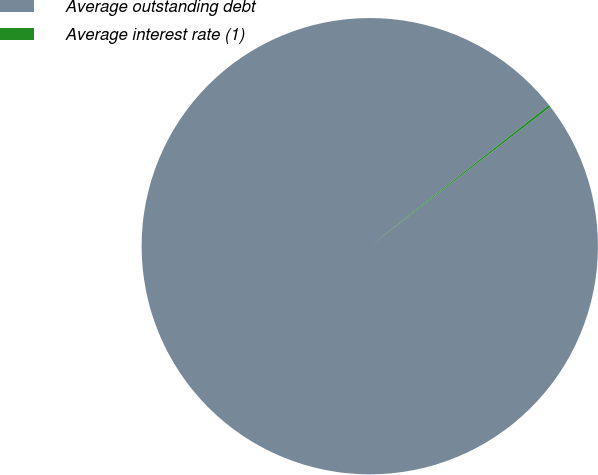Convert chart. <chart><loc_0><loc_0><loc_500><loc_500><pie_chart><fcel>Average outstanding debt<fcel>Average interest rate (1)<nl><fcel>99.84%<fcel>0.16%<nl></chart> 